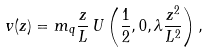<formula> <loc_0><loc_0><loc_500><loc_500>v ( z ) = m _ { q } \frac { z } { L } \, U \left ( \frac { 1 } { 2 } , 0 , \lambda \frac { z ^ { 2 } } { L ^ { 2 } } \right ) ,</formula> 